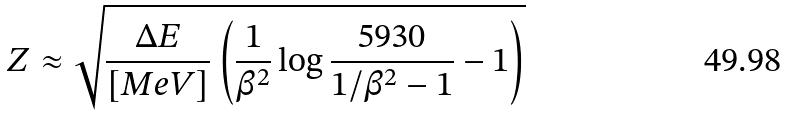<formula> <loc_0><loc_0><loc_500><loc_500>Z \approx \sqrt { \frac { \Delta E } { \left [ M e V \right ] } \left ( \frac { 1 } { \beta ^ { 2 } } \log { \frac { 5 9 3 0 } { 1 / \beta ^ { 2 } - 1 } } - 1 \right ) }</formula> 